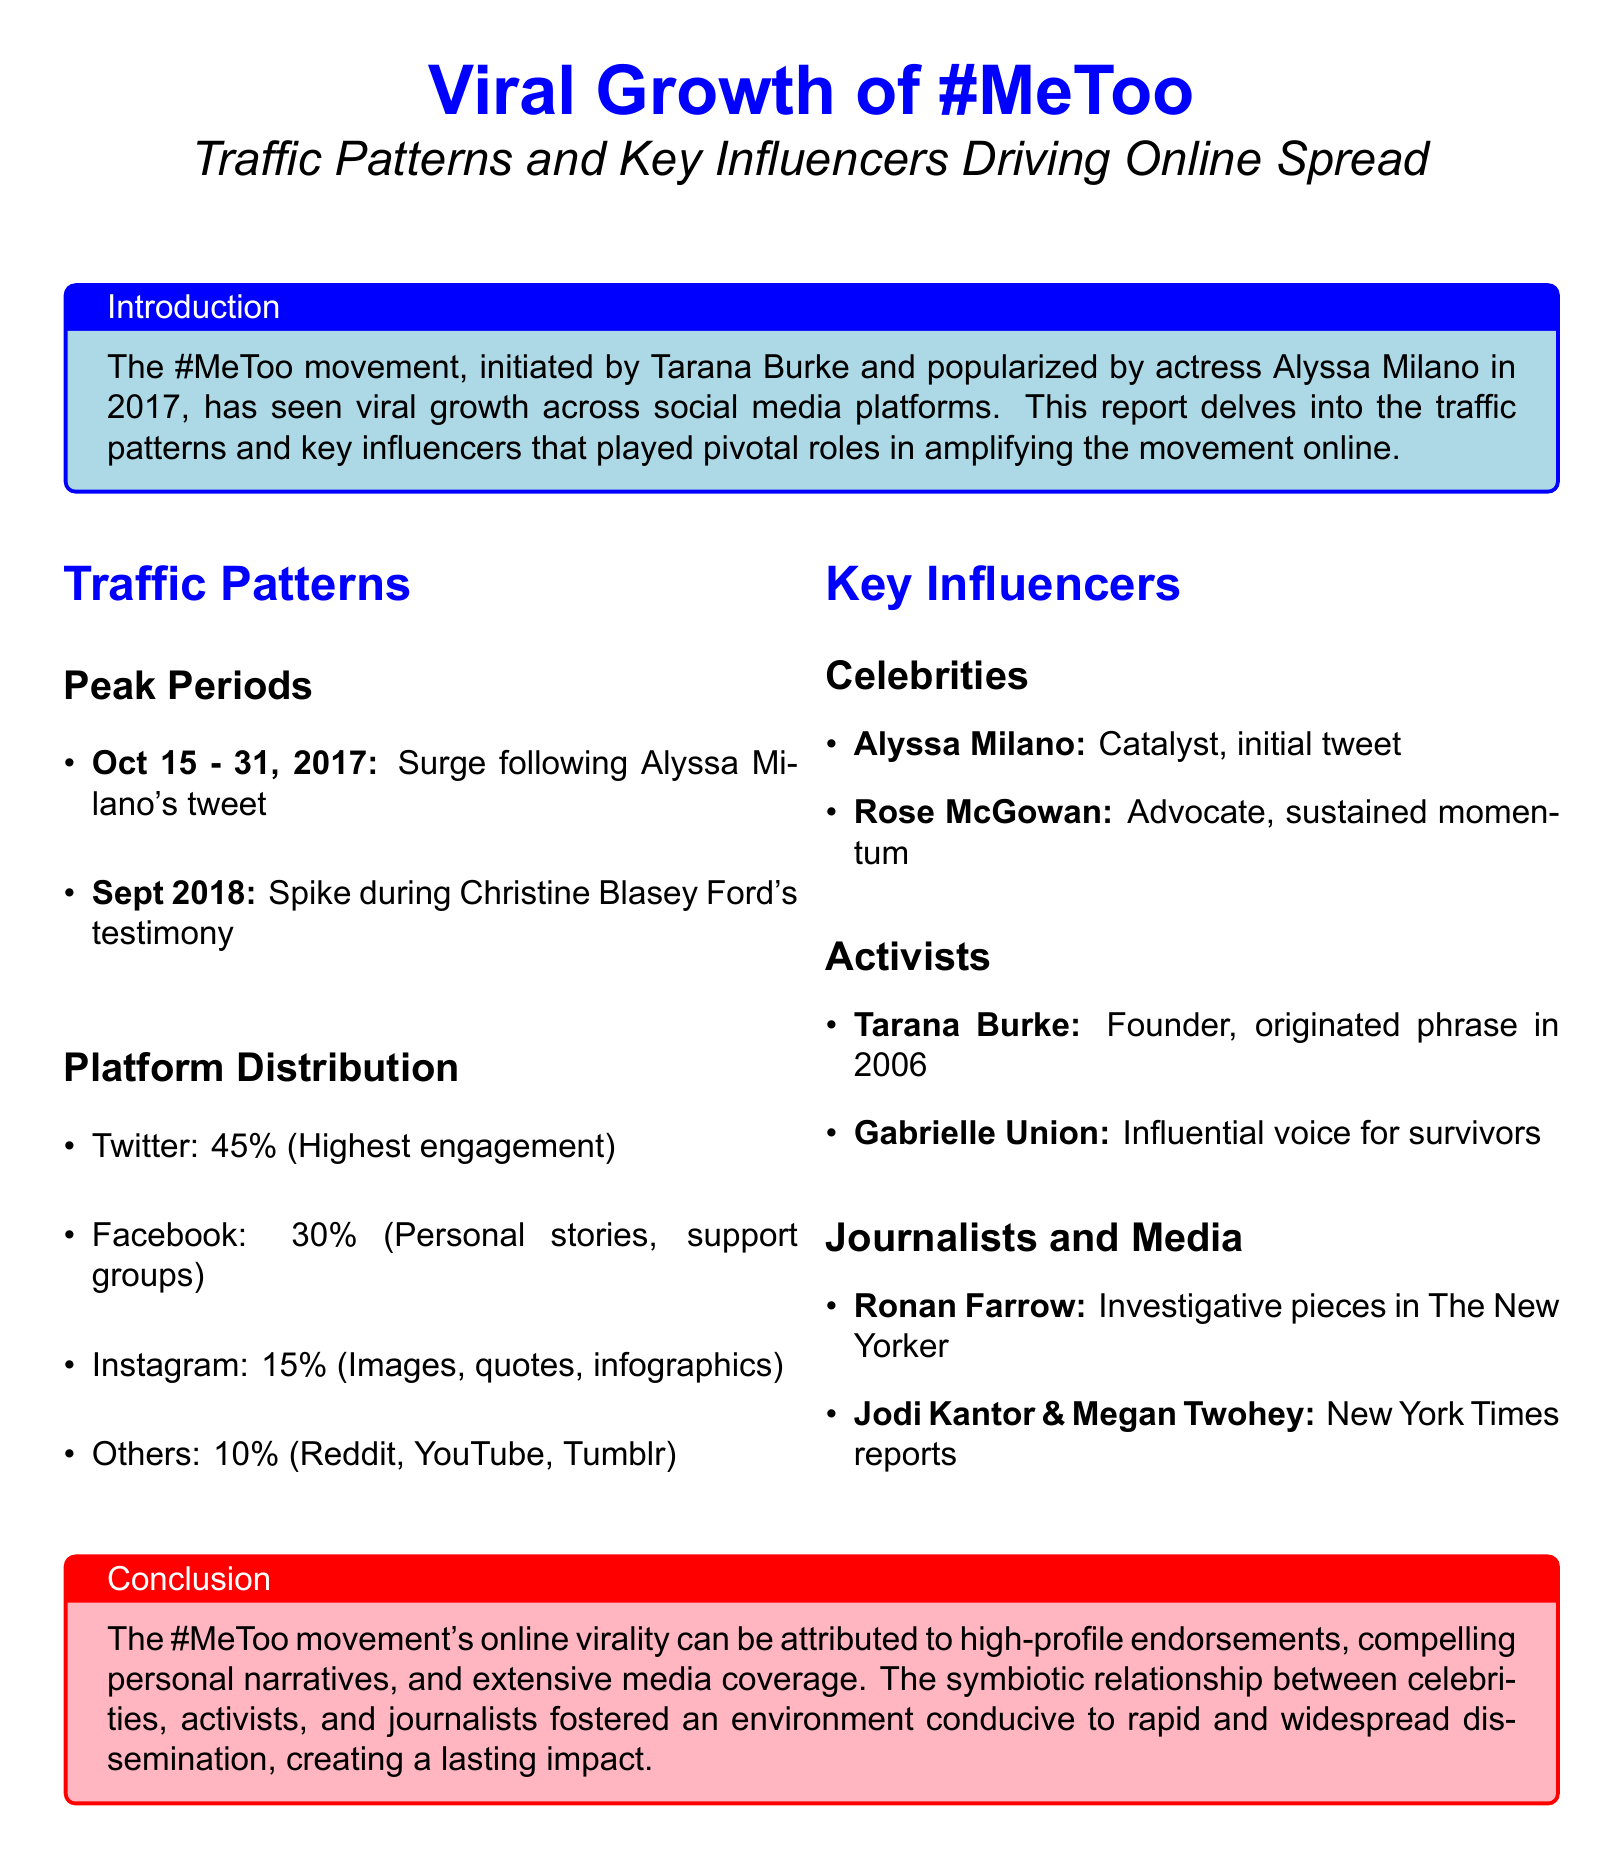What was the peak period for the #MeToo movement? The peak period for the #MeToo movement was between October 15 and 31, 2017, following Alyssa Milano's tweet.
Answer: October 15 - 31, 2017 Which celebrity is known as a catalyst for the #MeToo movement? Alyssa Milano is recognized as a catalyst for the #MeToo movement, initiating it with her tweet.
Answer: Alyssa Milano What percentage of engagement did Twitter have for the movement? The document states that Twitter had the highest engagement at 45%.
Answer: 45% Who was the founder of the #MeToo movement? The document identifies Tarana Burke as the founder of the #MeToo movement, having originated the phrase in 2006.
Answer: Tarana Burke What type of content saw a 30% distribution on Facebook? The document mentions that Facebook had a 30% distribution for personal stories and support groups.
Answer: Personal stories, support groups Which testimony led to a spike in traffic in September 2018? The spike in September 2018 was during Christine Blasey Ford's testimony.
Answer: Christine Blasey Ford's testimony Who are the journalists mentioned as key influencers? The key journalists mentioned are Ronan Farrow, Jodi Kantor, and Megan Twohey.
Answer: Ronan Farrow, Jodi Kantor & Megan Twohey What is a significant conclusion drawn about the #MeToo movement? The conclusion emphasizes the role of high-profile endorsements and media coverage in the movement's virality.
Answer: High-profile endorsements and media coverage What platforms are included under "Others" in platform distribution? The "Others" category includes Reddit, YouTube, and Tumblr.
Answer: Reddit, YouTube, Tumblr 